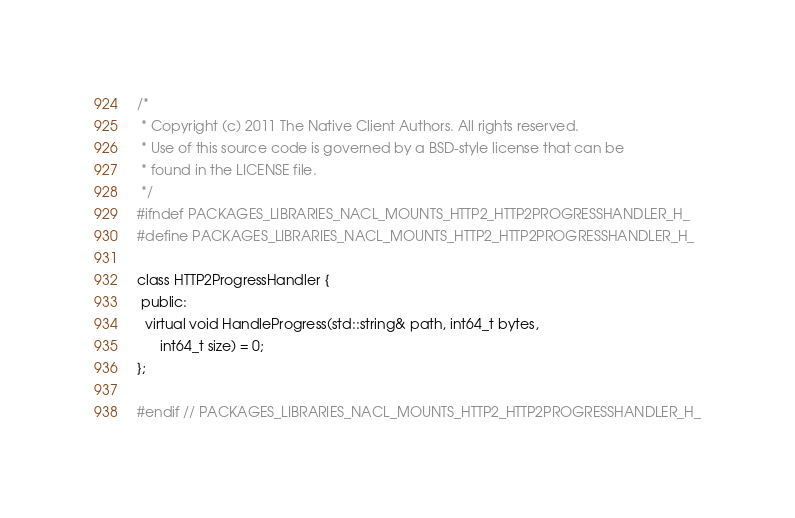<code> <loc_0><loc_0><loc_500><loc_500><_C_>/*
 * Copyright (c) 2011 The Native Client Authors. All rights reserved.
 * Use of this source code is governed by a BSD-style license that can be
 * found in the LICENSE file.
 */
#ifndef PACKAGES_LIBRARIES_NACL_MOUNTS_HTTP2_HTTP2PROGRESSHANDLER_H_
#define PACKAGES_LIBRARIES_NACL_MOUNTS_HTTP2_HTTP2PROGRESSHANDLER_H_

class HTTP2ProgressHandler {
 public:
  virtual void HandleProgress(std::string& path, int64_t bytes,
      int64_t size) = 0;
};

#endif // PACKAGES_LIBRARIES_NACL_MOUNTS_HTTP2_HTTP2PROGRESSHANDLER_H_
</code> 